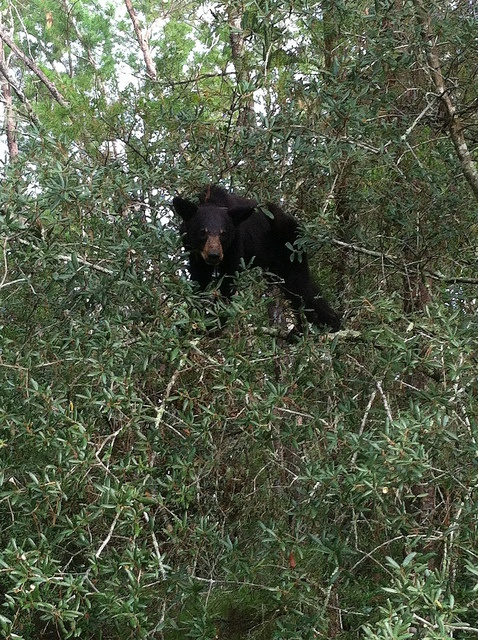Describe the objects in this image and their specific colors. I can see a bear in darkgray, black, gray, and darkgreen tones in this image. 